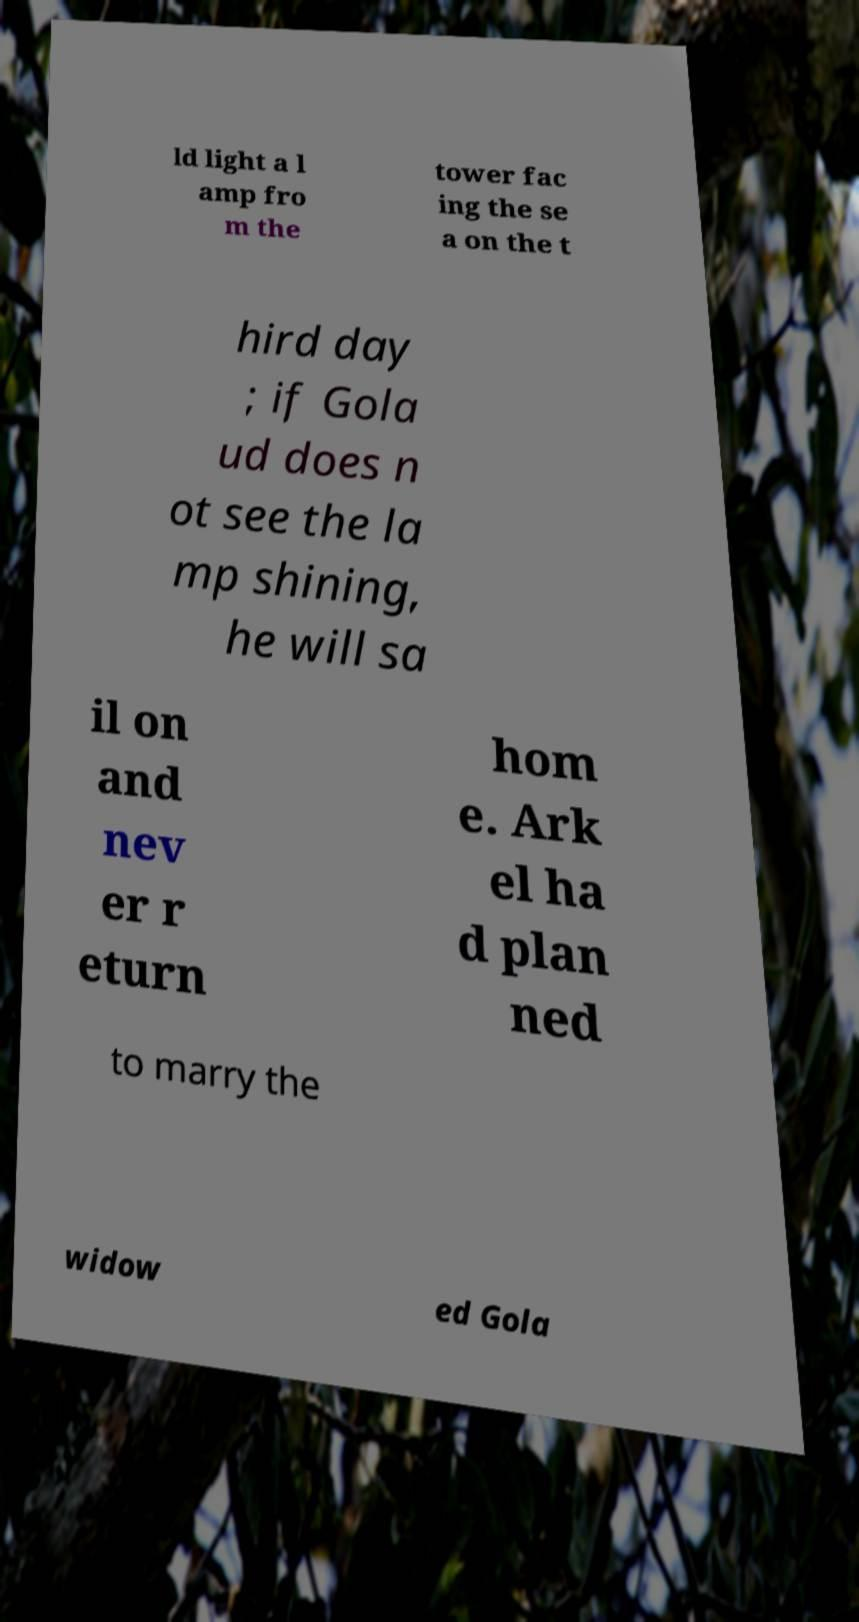There's text embedded in this image that I need extracted. Can you transcribe it verbatim? ld light a l amp fro m the tower fac ing the se a on the t hird day ; if Gola ud does n ot see the la mp shining, he will sa il on and nev er r eturn hom e. Ark el ha d plan ned to marry the widow ed Gola 